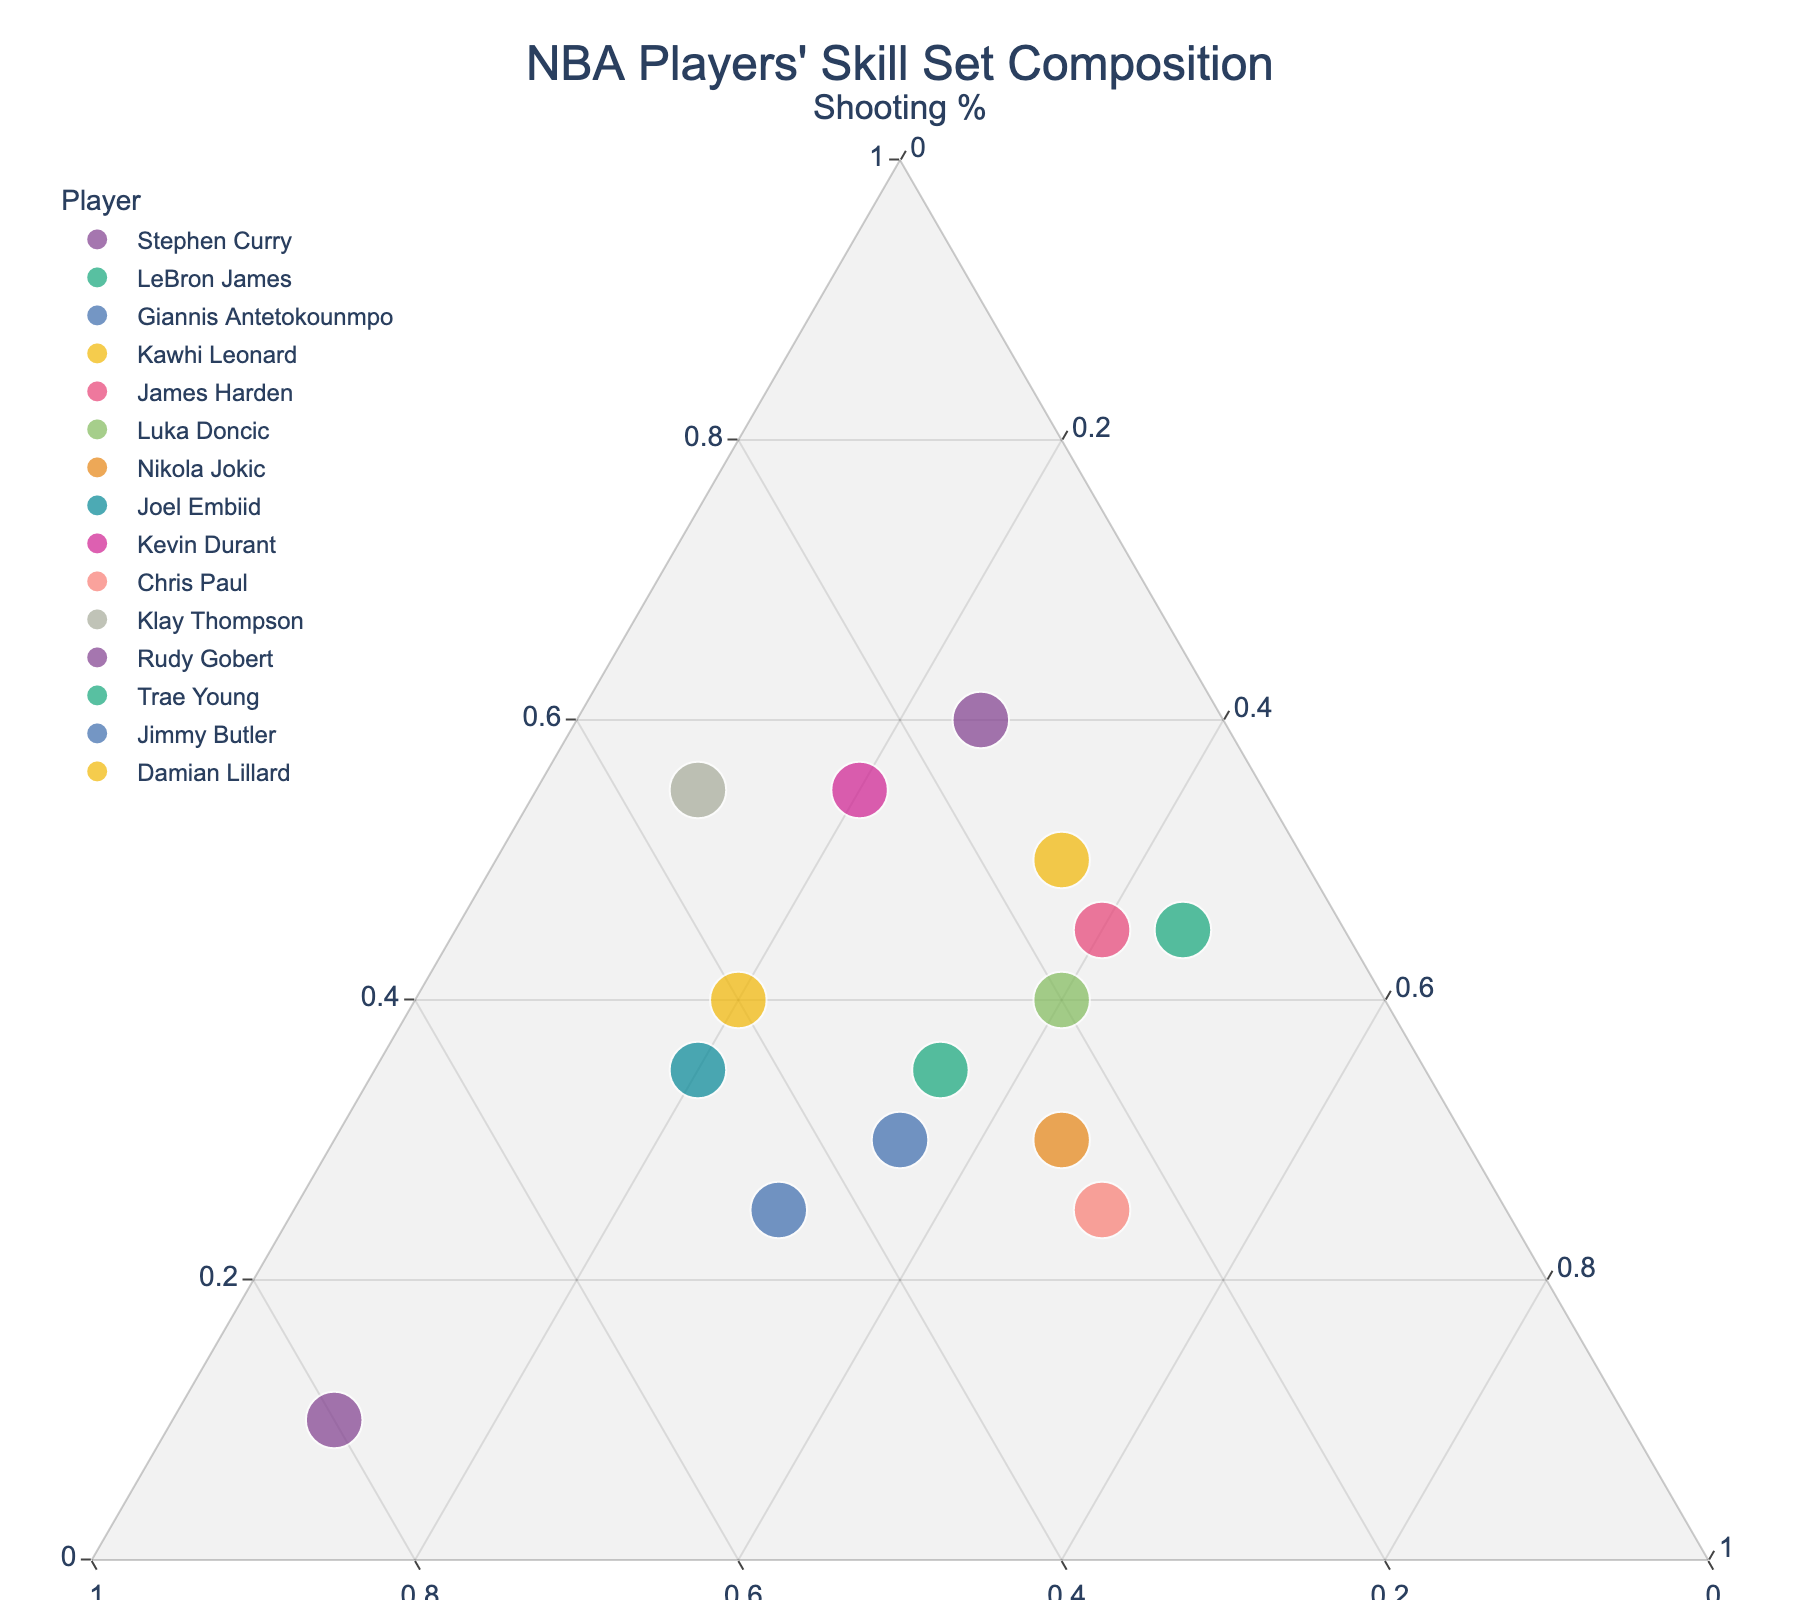What's the title of the figure? The title is usually placed at the top of the figure. It gives a clear idea about what the plot is showcasing.
Answer: NBA Players' Skill Set Composition How many players have at least 50% in either shooting or playmaking? We look for players with shooting or playmaking values of 50% or more. Damian Lillard, Stephen Curry, Klay Thompson, and Trae Young have shooting 50% or more, while James Harden, Luka Doncic, Trae Young, and Chris Paul have playmaking 50% or more. Considering overlaps, players meeting criteria are Stephen Curry, James Harden, Luka Doncic, Trae Young, Damian Lillard, Klay Thompson, and Chris Paul.
Answer: 7 Who has the highest defense percentage and what is it? We identify the player with the highest defense percentage by looking at the value in the Defense column; Rudy Gobert has the highest defense percentage at 80%.
Answer: Rudy Gobert, 80% What is the average shooting percentage of players who have a defense percentage greater than 40%? We filter out players with defense greater than 40% (i.e., Giannis Antetokounmpo, Joel Embiid, Rudy Gobert). Their shooting percentages are 25%, 35%, and 10%. Average is calculated as (25 + 35 + 10) / 3 = 23.33%.
Answer: 23.33% Compare Stephen Curry and LeBron James: who has a higher playmaking percentage? By comparing their playmaking percentages directly from the data, LeBron James has 35%, and Stephen Curry has 25%. LeBron James has a higher playmaking percentage.
Answer: LeBron James Which player has a balanced skill set with similar percentages across all three categories? We look for a player whose percentages in shooting, defense, and playmaking are close to each other without large deviations. LeBron James (35, 30, 35) and Jimmy Butler (30, 35, 35) are close to balance.
Answer: Jimmy Butler or LeBron James How many players have a shooting percentage higher than their defense percentage? We compare shooting and defense percentages for each player. Players where shooting > defense are Stephen Curry, James Harden, Luka Doncic, Kevin Durant, Trae Young, and Damian Lillard.
Answer: 6 Who excels the most in playmaking and what is the percentage? By identifying the highest playmaking percentage in the data, Chris Paul excels the most with 50%.
Answer: Chris Paul, 50% Who has the lowest combination of shooting and defense and what is the cumulative percentage? By summing shooting and defense values for each player and identifying the minimum, Rudy Gobert has the lowest combination (10 + 80 = 90). Cumulative percentage of 90%.
Answer: Rudy Gobert, 90% Is there any player whose skill set is equally divided between shooting, defense, and playmaking? A player with an equally divided skill set would have values of about 33% in each category. None of the players listed have an equally divided skill set.
Answer: No 